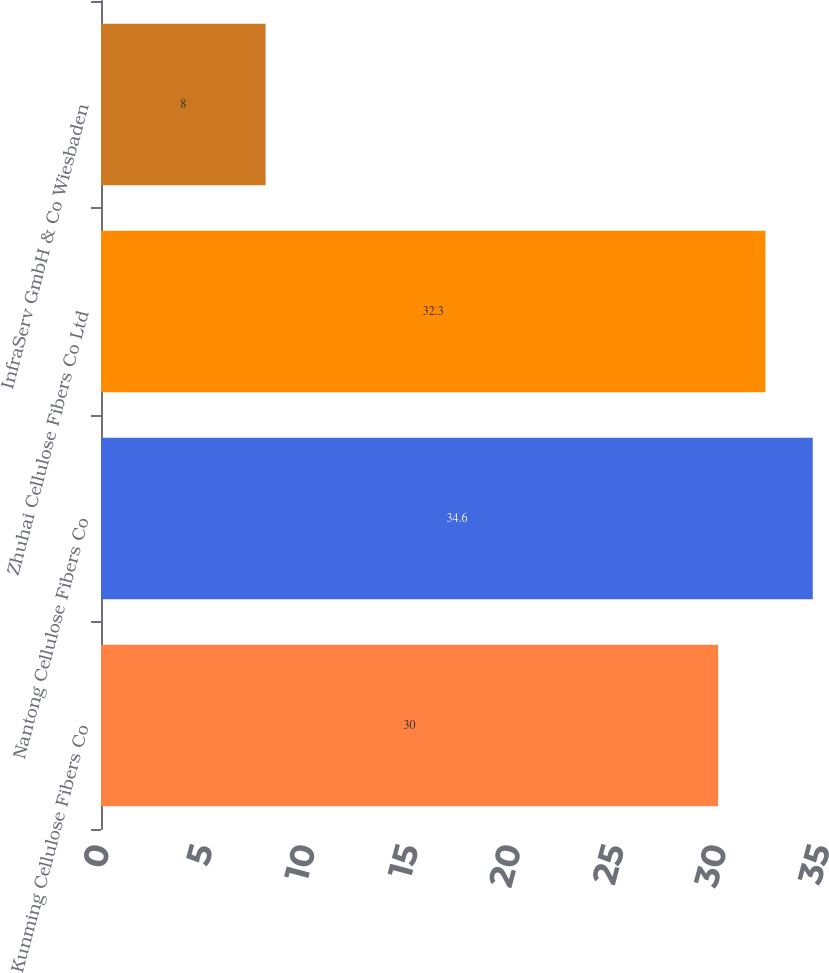<chart> <loc_0><loc_0><loc_500><loc_500><bar_chart><fcel>Kunming Cellulose Fibers Co<fcel>Nantong Cellulose Fibers Co<fcel>Zhuhai Cellulose Fibers Co Ltd<fcel>InfraServ GmbH & Co Wiesbaden<nl><fcel>30<fcel>34.6<fcel>32.3<fcel>8<nl></chart> 